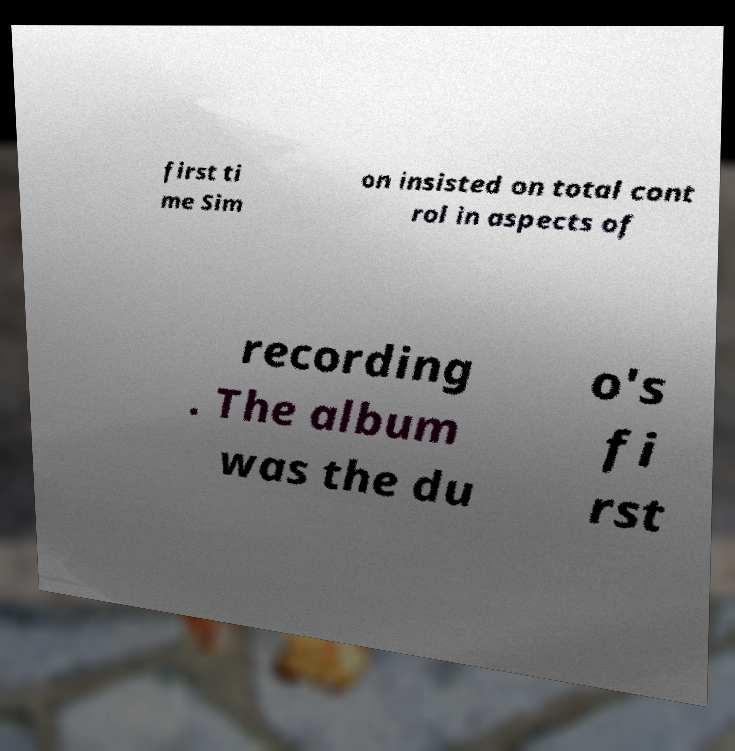For documentation purposes, I need the text within this image transcribed. Could you provide that? first ti me Sim on insisted on total cont rol in aspects of recording . The album was the du o's fi rst 